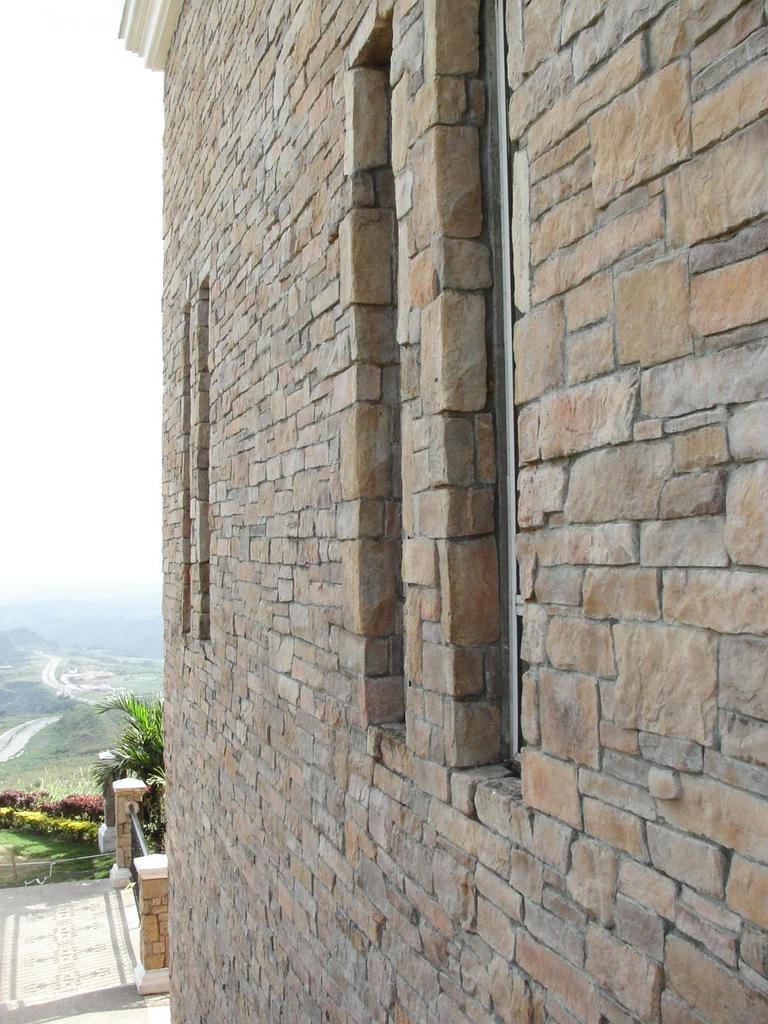What type of building is depicted in the image? There is a building made up of rocks in the image. What architectural features can be seen in the background of the image? There are two pillars in the background of the image. What type of vegetation is visible in the background of the image? There are trees in the background of the image. What part of the natural environment is visible in the image? The ground and the sky are visible in the image. What type of toothpaste is being used to clean the rocks in the image? There is no toothpaste present in the image, and the rocks are not being cleaned. 